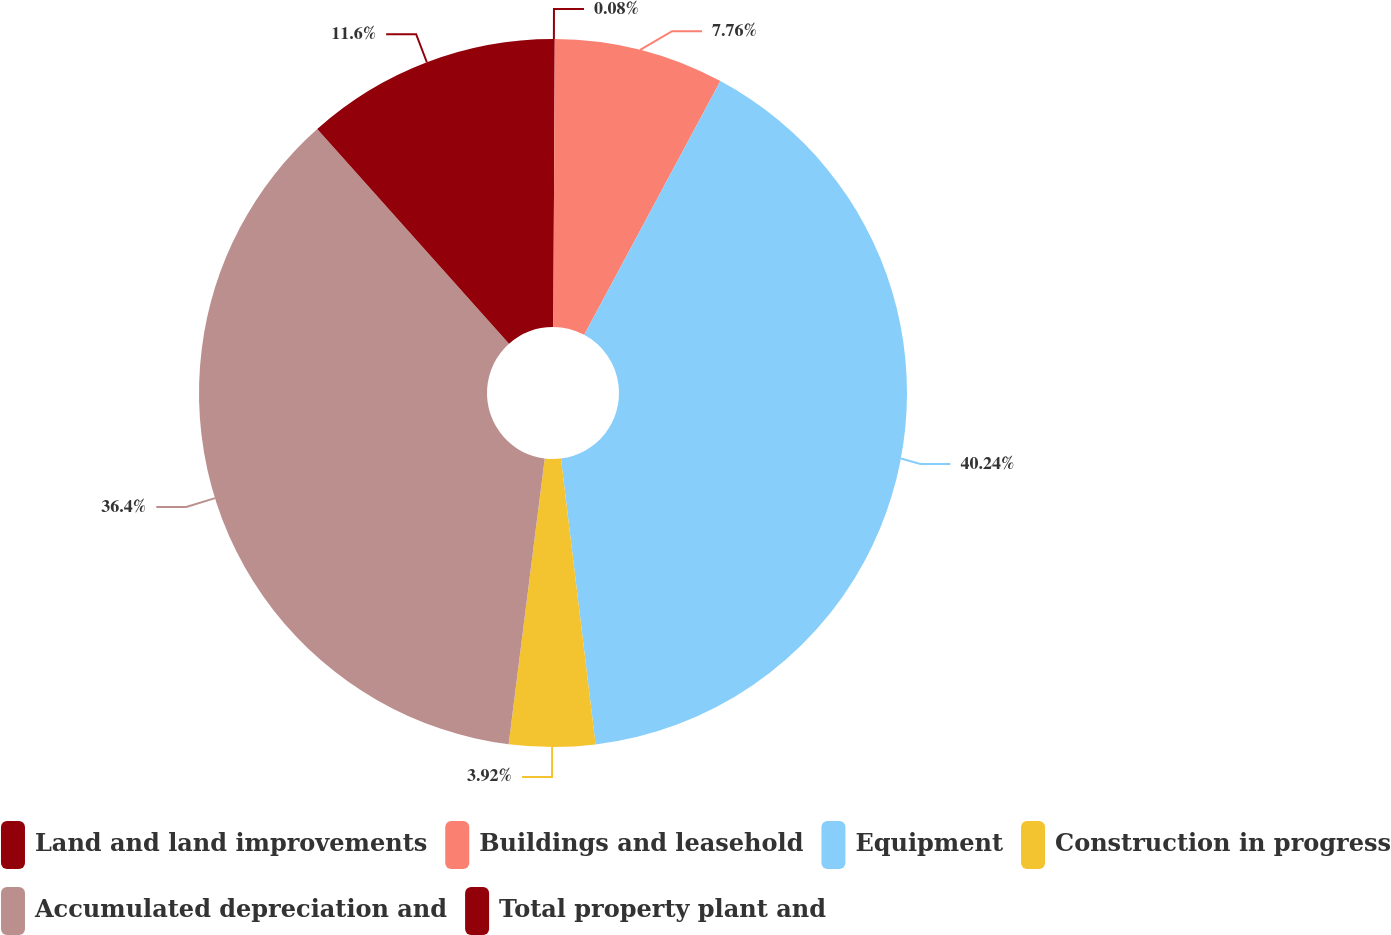<chart> <loc_0><loc_0><loc_500><loc_500><pie_chart><fcel>Land and land improvements<fcel>Buildings and leasehold<fcel>Equipment<fcel>Construction in progress<fcel>Accumulated depreciation and<fcel>Total property plant and<nl><fcel>0.08%<fcel>7.76%<fcel>40.24%<fcel>3.92%<fcel>36.4%<fcel>11.6%<nl></chart> 